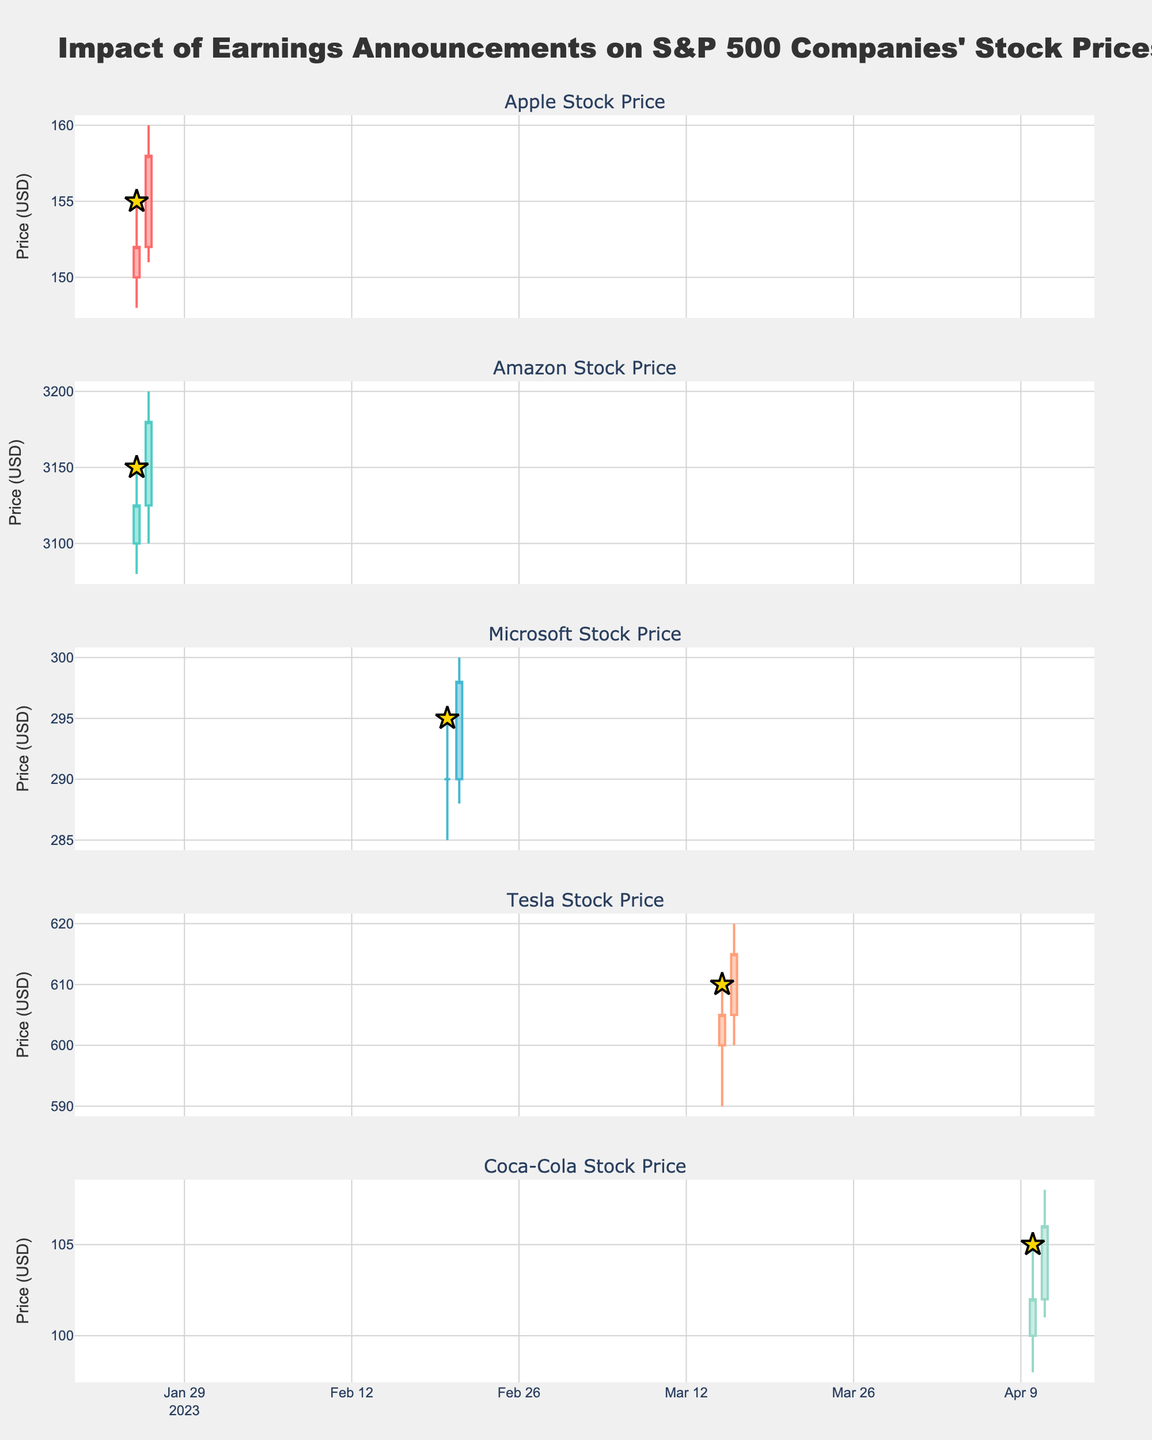Which company had the highest price increase from one day to the next after the earnings announcement? Compare the closing prices before and after earnings for each company. Apple's close went from 152 to 158 (+6), Amazon's from 3125 to 3180 (+55), Microsoft's from 290 to 298 (+8), Tesla's from 605 to 615 (+10), and Coca-Cola's from 102 to 106 (+4). Amazon had the highest increase of 55.
Answer: Amazon What was the closing price of Tesla on the day of its earnings announcement? Locate the closing price for Tesla on 2023-03-15, which is the earnings date. The closing price on that day is 605.
Answer: 605 How did Coca-Cola's stock price react the day after its earnings announcement? Coca-Cola's earnings announcement was on 2023-04-10. Compare the closing prices on 2023-04-10 and 2023-04-11. The price increased from 102 to 106.
Answer: Increased Which company showed the smallest price movement in the day following the earnings announcement? Compare the price change from one day to the next for all companies after earnings announcements: Apple's change (152 to 158) = 6, Amazon's (3125 to 3180) = 55, Microsoft's (290 to 298) = 8, Tesla's (605 to 615) = 10, Coca-Cola's (102 to 106) = 4. Coca-Cola had the smallest change of 4.
Answer: Coca-Cola Did Microsoft's stock price increase or decrease after its earnings announcement? Check the closing prices of Microsoft on 2023-02-20 and 2023-02-21. The price increased from 290 to 298.
Answer: Increase What was the highest trading volume observed in the data set? Scan the 'Volume' column for all companies and dates. The highest volume is 1,500,000 on 2023-01-26 for Apple.
Answer: 1,500,000 Which company had the highest closing price on the date of its earnings announcement? Compare the closing prices on the earnings dates for all companies: Apple's 152, Amazon's 3125, Microsoft's 290, Tesla's 605, Coca-Cola's 102. Amazon had the highest closing price of 3125.
Answer: Amazon How many companies experienced an increase in their stock price the day after their earnings announcement? Compare the closing prices before and after earnings for each company: Apple (increase), Amazon (increase), Microsoft (increase), Tesla (increase), Coca-Cola (increase). All 5 companies experienced an increase.
Answer: 5 